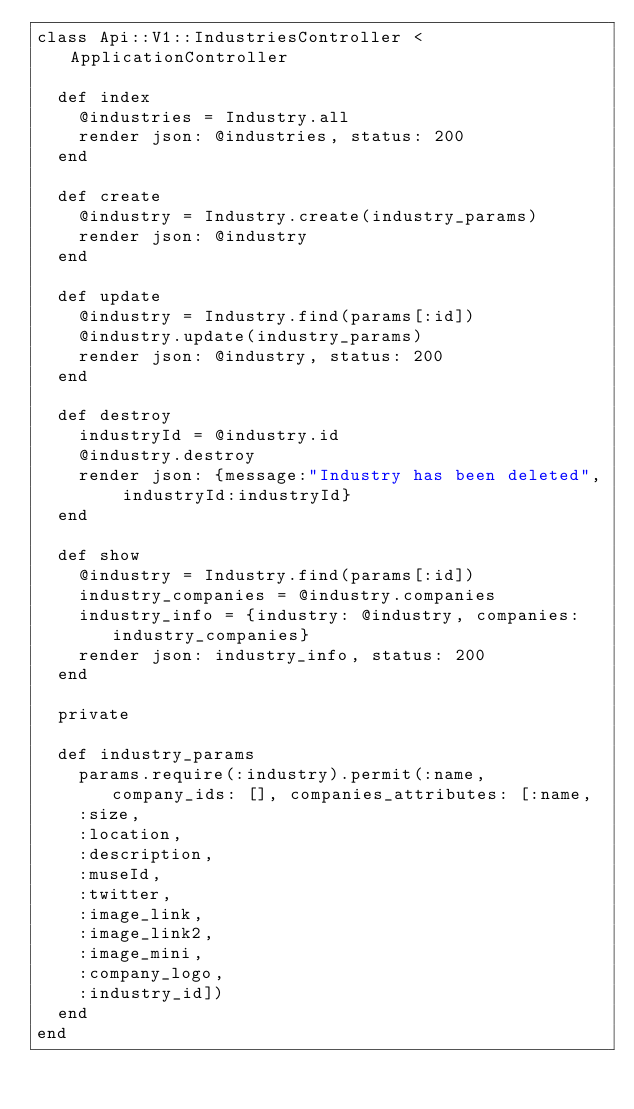Convert code to text. <code><loc_0><loc_0><loc_500><loc_500><_Ruby_>class Api::V1::IndustriesController < ApplicationController

  def index
    @industries = Industry.all
    render json: @industries, status: 200
  end

  def create
    @industry = Industry.create(industry_params)
    render json: @industry
  end

  def update
    @industry = Industry.find(params[:id])
    @industry.update(industry_params)
    render json: @industry, status: 200
  end

  def destroy
    industryId = @industry.id
    @industry.destroy
    render json: {message:"Industry has been deleted", industryId:industryId}
  end

  def show
    @industry = Industry.find(params[:id])
    industry_companies = @industry.companies
    industry_info = {industry: @industry, companies: industry_companies}
    render json: industry_info, status: 200
  end

  private

  def industry_params
    params.require(:industry).permit(:name, company_ids: [], companies_attributes: [:name,
    :size,
    :location,
    :description,
    :museId,
    :twitter,
    :image_link,
    :image_link2,
    :image_mini,
    :company_logo,
    :industry_id])
  end
end
</code> 